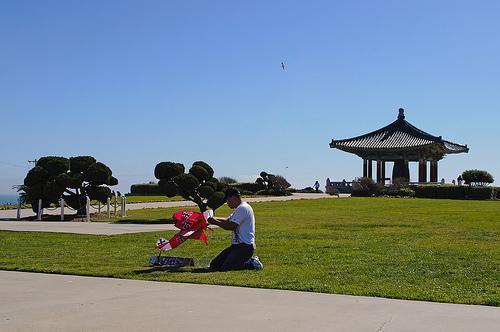How many men?
Give a very brief answer. 1. 